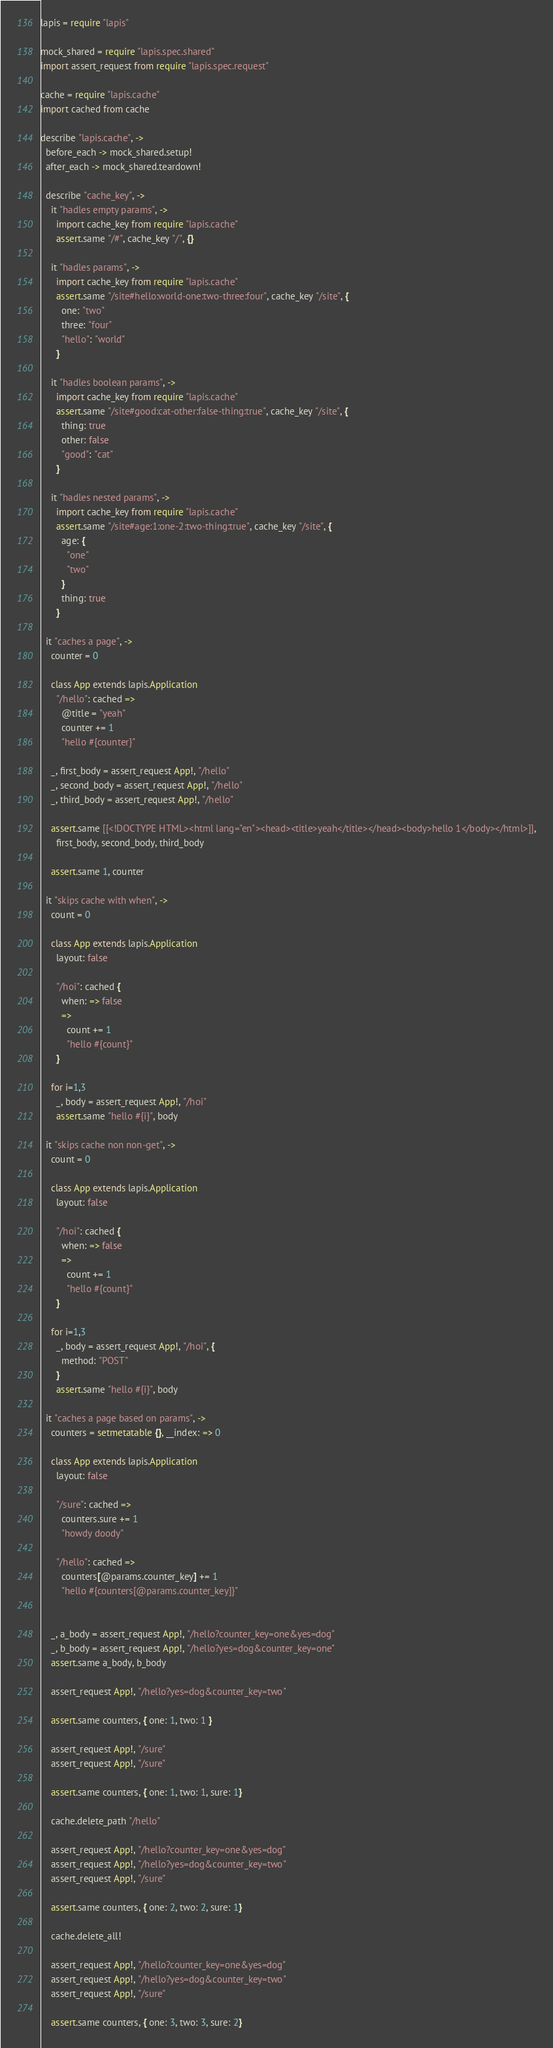<code> <loc_0><loc_0><loc_500><loc_500><_MoonScript_>lapis = require "lapis"

mock_shared = require "lapis.spec.shared"
import assert_request from require "lapis.spec.request"

cache = require "lapis.cache"
import cached from cache

describe "lapis.cache", ->
  before_each -> mock_shared.setup!
  after_each -> mock_shared.teardown!

  describe "cache_key", ->
    it "hadles empty params", ->
      import cache_key from require "lapis.cache"
      assert.same "/#", cache_key "/", {}

    it "hadles params", ->
      import cache_key from require "lapis.cache"
      assert.same "/site#hello:world-one:two-three:four", cache_key "/site", {
        one: "two"
        three: "four"
        "hello": "world"
      }

    it "hadles boolean params", ->
      import cache_key from require "lapis.cache"
      assert.same "/site#good:cat-other:false-thing:true", cache_key "/site", {
        thing: true
        other: false
        "good": "cat"
      }

    it "hadles nested params", ->
      import cache_key from require "lapis.cache"
      assert.same "/site#age:1:one-2:two-thing:true", cache_key "/site", {
        age: {
          "one"
          "two"
        }
        thing: true
      }

  it "caches a page", ->
    counter = 0

    class App extends lapis.Application
      "/hello": cached =>
        @title = "yeah"
        counter += 1
        "hello #{counter}"

    _, first_body = assert_request App!, "/hello"
    _, second_body = assert_request App!, "/hello"
    _, third_body = assert_request App!, "/hello"

    assert.same [[<!DOCTYPE HTML><html lang="en"><head><title>yeah</title></head><body>hello 1</body></html>]],
      first_body, second_body, third_body

    assert.same 1, counter

  it "skips cache with when", ->
    count = 0

    class App extends lapis.Application
      layout: false

      "/hoi": cached {
        when: => false
        =>
          count += 1
          "hello #{count}"
      }

    for i=1,3
      _, body = assert_request App!, "/hoi"
      assert.same "hello #{i}", body

  it "skips cache non non-get", ->
    count = 0

    class App extends lapis.Application
      layout: false

      "/hoi": cached {
        when: => false
        =>
          count += 1
          "hello #{count}"
      }

    for i=1,3
      _, body = assert_request App!, "/hoi", {
        method: "POST"
      }
      assert.same "hello #{i}", body

  it "caches a page based on params", ->
    counters = setmetatable {}, __index: => 0

    class App extends lapis.Application
      layout: false

      "/sure": cached =>
        counters.sure += 1
        "howdy doody"

      "/hello": cached =>
        counters[@params.counter_key] += 1
        "hello #{counters[@params.counter_key]}"


    _, a_body = assert_request App!, "/hello?counter_key=one&yes=dog"
    _, b_body = assert_request App!, "/hello?yes=dog&counter_key=one"
    assert.same a_body, b_body

    assert_request App!, "/hello?yes=dog&counter_key=two"

    assert.same counters, { one: 1, two: 1 }

    assert_request App!, "/sure"
    assert_request App!, "/sure"

    assert.same counters, { one: 1, two: 1, sure: 1}

    cache.delete_path "/hello"

    assert_request App!, "/hello?counter_key=one&yes=dog"
    assert_request App!, "/hello?yes=dog&counter_key=two"
    assert_request App!, "/sure"

    assert.same counters, { one: 2, two: 2, sure: 1}

    cache.delete_all!

    assert_request App!, "/hello?counter_key=one&yes=dog"
    assert_request App!, "/hello?yes=dog&counter_key=two"
    assert_request App!, "/sure"

    assert.same counters, { one: 3, two: 3, sure: 2}



</code> 